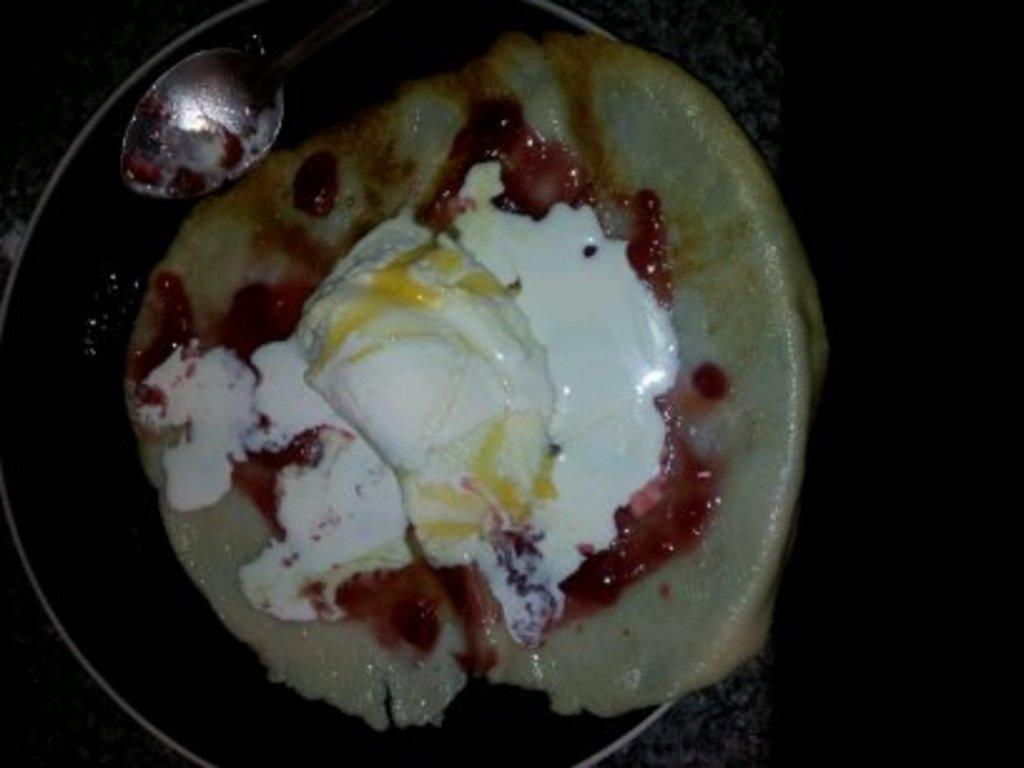What is in the bowl that is visible in the image? There is food in a bowl in the image. What utensil is used to eat the food in the image? There is a spoon in the bowl in the image. Can you describe the texture of the bottom of the image? The bottom of the image appears to have a marble-like texture. What color is the background on the right side of the image? The background on the right side of the image is black. What type of advertisement can be seen on the left side of the image? There is no advertisement present in the image. Can you tell me how many frogs are sitting on the bulb in the image? There are no frogs or bulbs present in the image. 